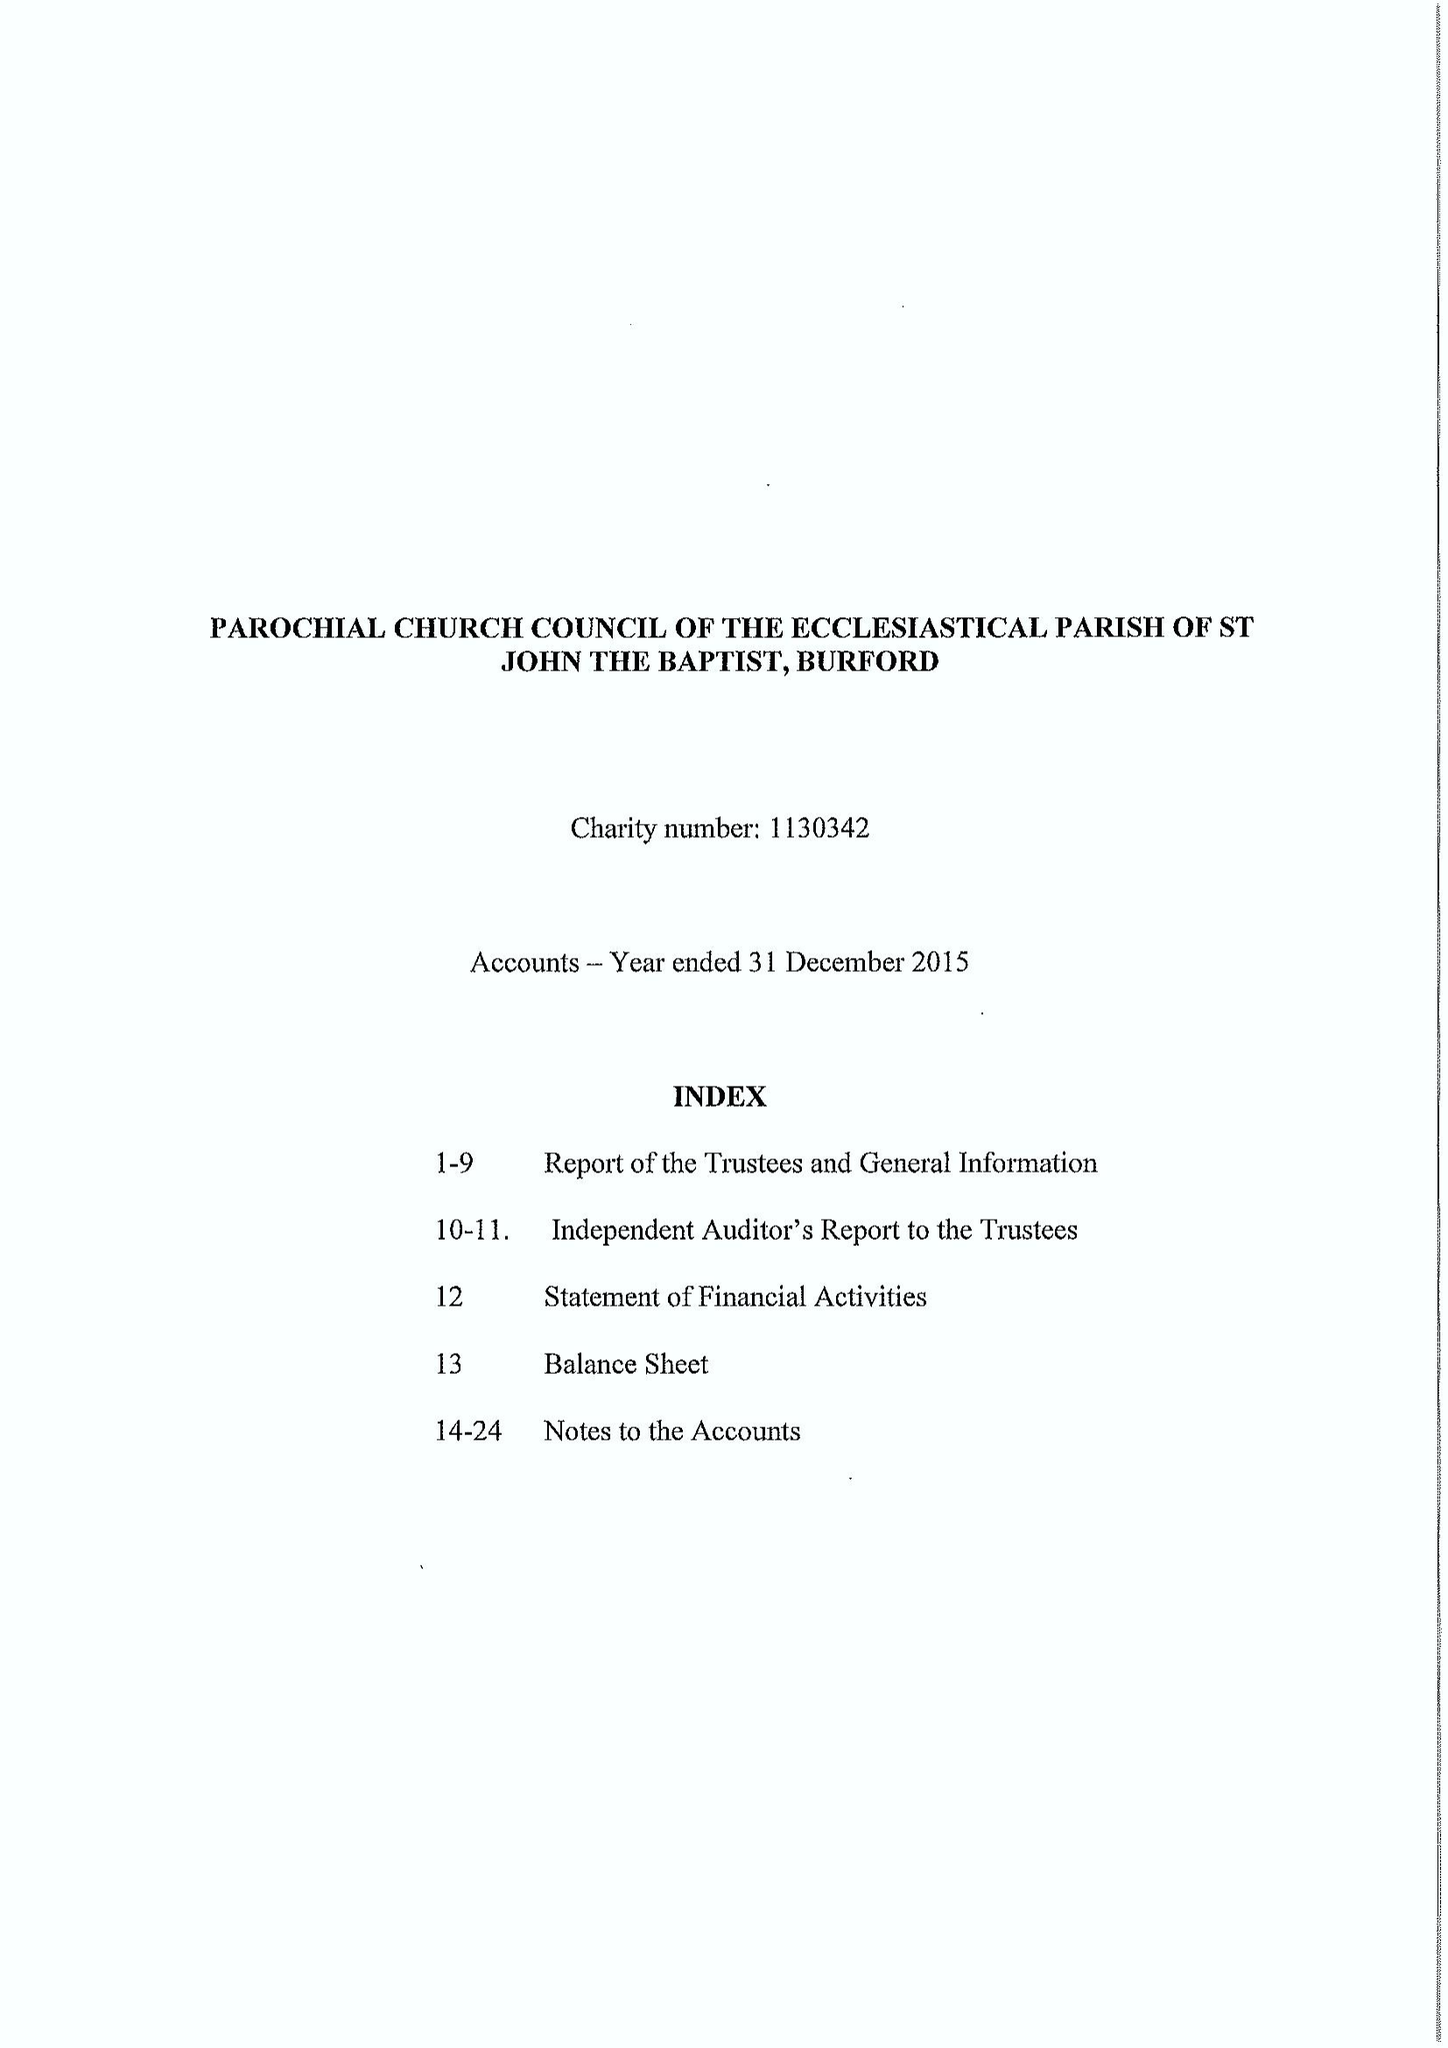What is the value for the charity_name?
Answer the question using a single word or phrase. The Parochial Church Council Of The Ecclesiastical Parish Of St John The Baptist, Burford 